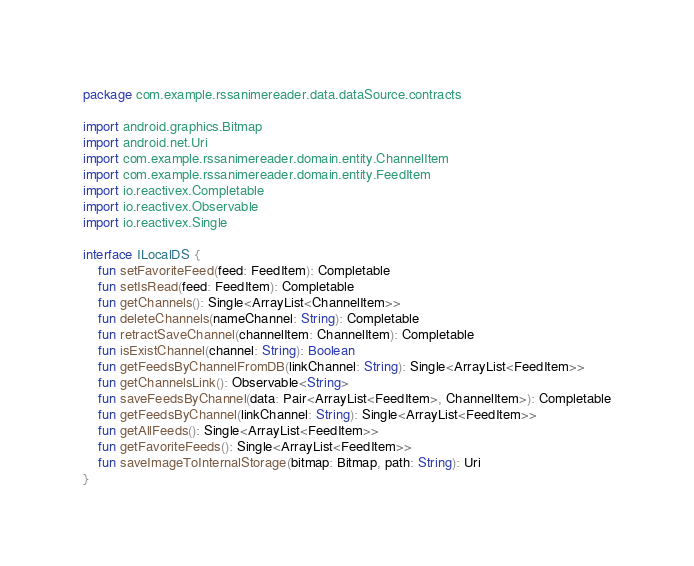<code> <loc_0><loc_0><loc_500><loc_500><_Kotlin_>package com.example.rssanimereader.data.dataSource.contracts

import android.graphics.Bitmap
import android.net.Uri
import com.example.rssanimereader.domain.entity.ChannelItem
import com.example.rssanimereader.domain.entity.FeedItem
import io.reactivex.Completable
import io.reactivex.Observable
import io.reactivex.Single

interface ILocalDS {
    fun setFavoriteFeed(feed: FeedItem): Completable
    fun setIsRead(feed: FeedItem): Completable
    fun getChannels(): Single<ArrayList<ChannelItem>>
    fun deleteChannels(nameChannel: String): Completable
    fun retractSaveChannel(channelItem: ChannelItem): Completable
    fun isExistChannel(channel: String): Boolean
    fun getFeedsByChannelFromDB(linkChannel: String): Single<ArrayList<FeedItem>>
    fun getChannelsLink(): Observable<String>
    fun saveFeedsByChannel(data: Pair<ArrayList<FeedItem>, ChannelItem>): Completable
    fun getFeedsByChannel(linkChannel: String): Single<ArrayList<FeedItem>>
    fun getAllFeeds(): Single<ArrayList<FeedItem>>
    fun getFavoriteFeeds(): Single<ArrayList<FeedItem>>
    fun saveImageToInternalStorage(bitmap: Bitmap, path: String): Uri
}</code> 